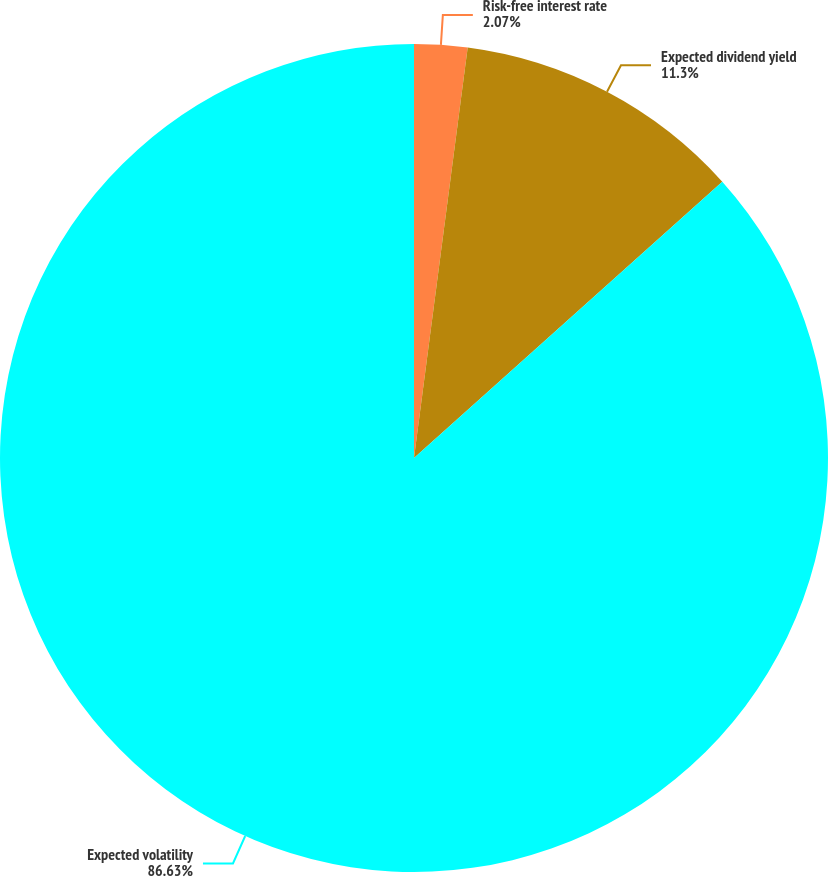Convert chart to OTSL. <chart><loc_0><loc_0><loc_500><loc_500><pie_chart><fcel>Risk-free interest rate<fcel>Expected dividend yield<fcel>Expected volatility<nl><fcel>2.07%<fcel>11.3%<fcel>86.64%<nl></chart> 